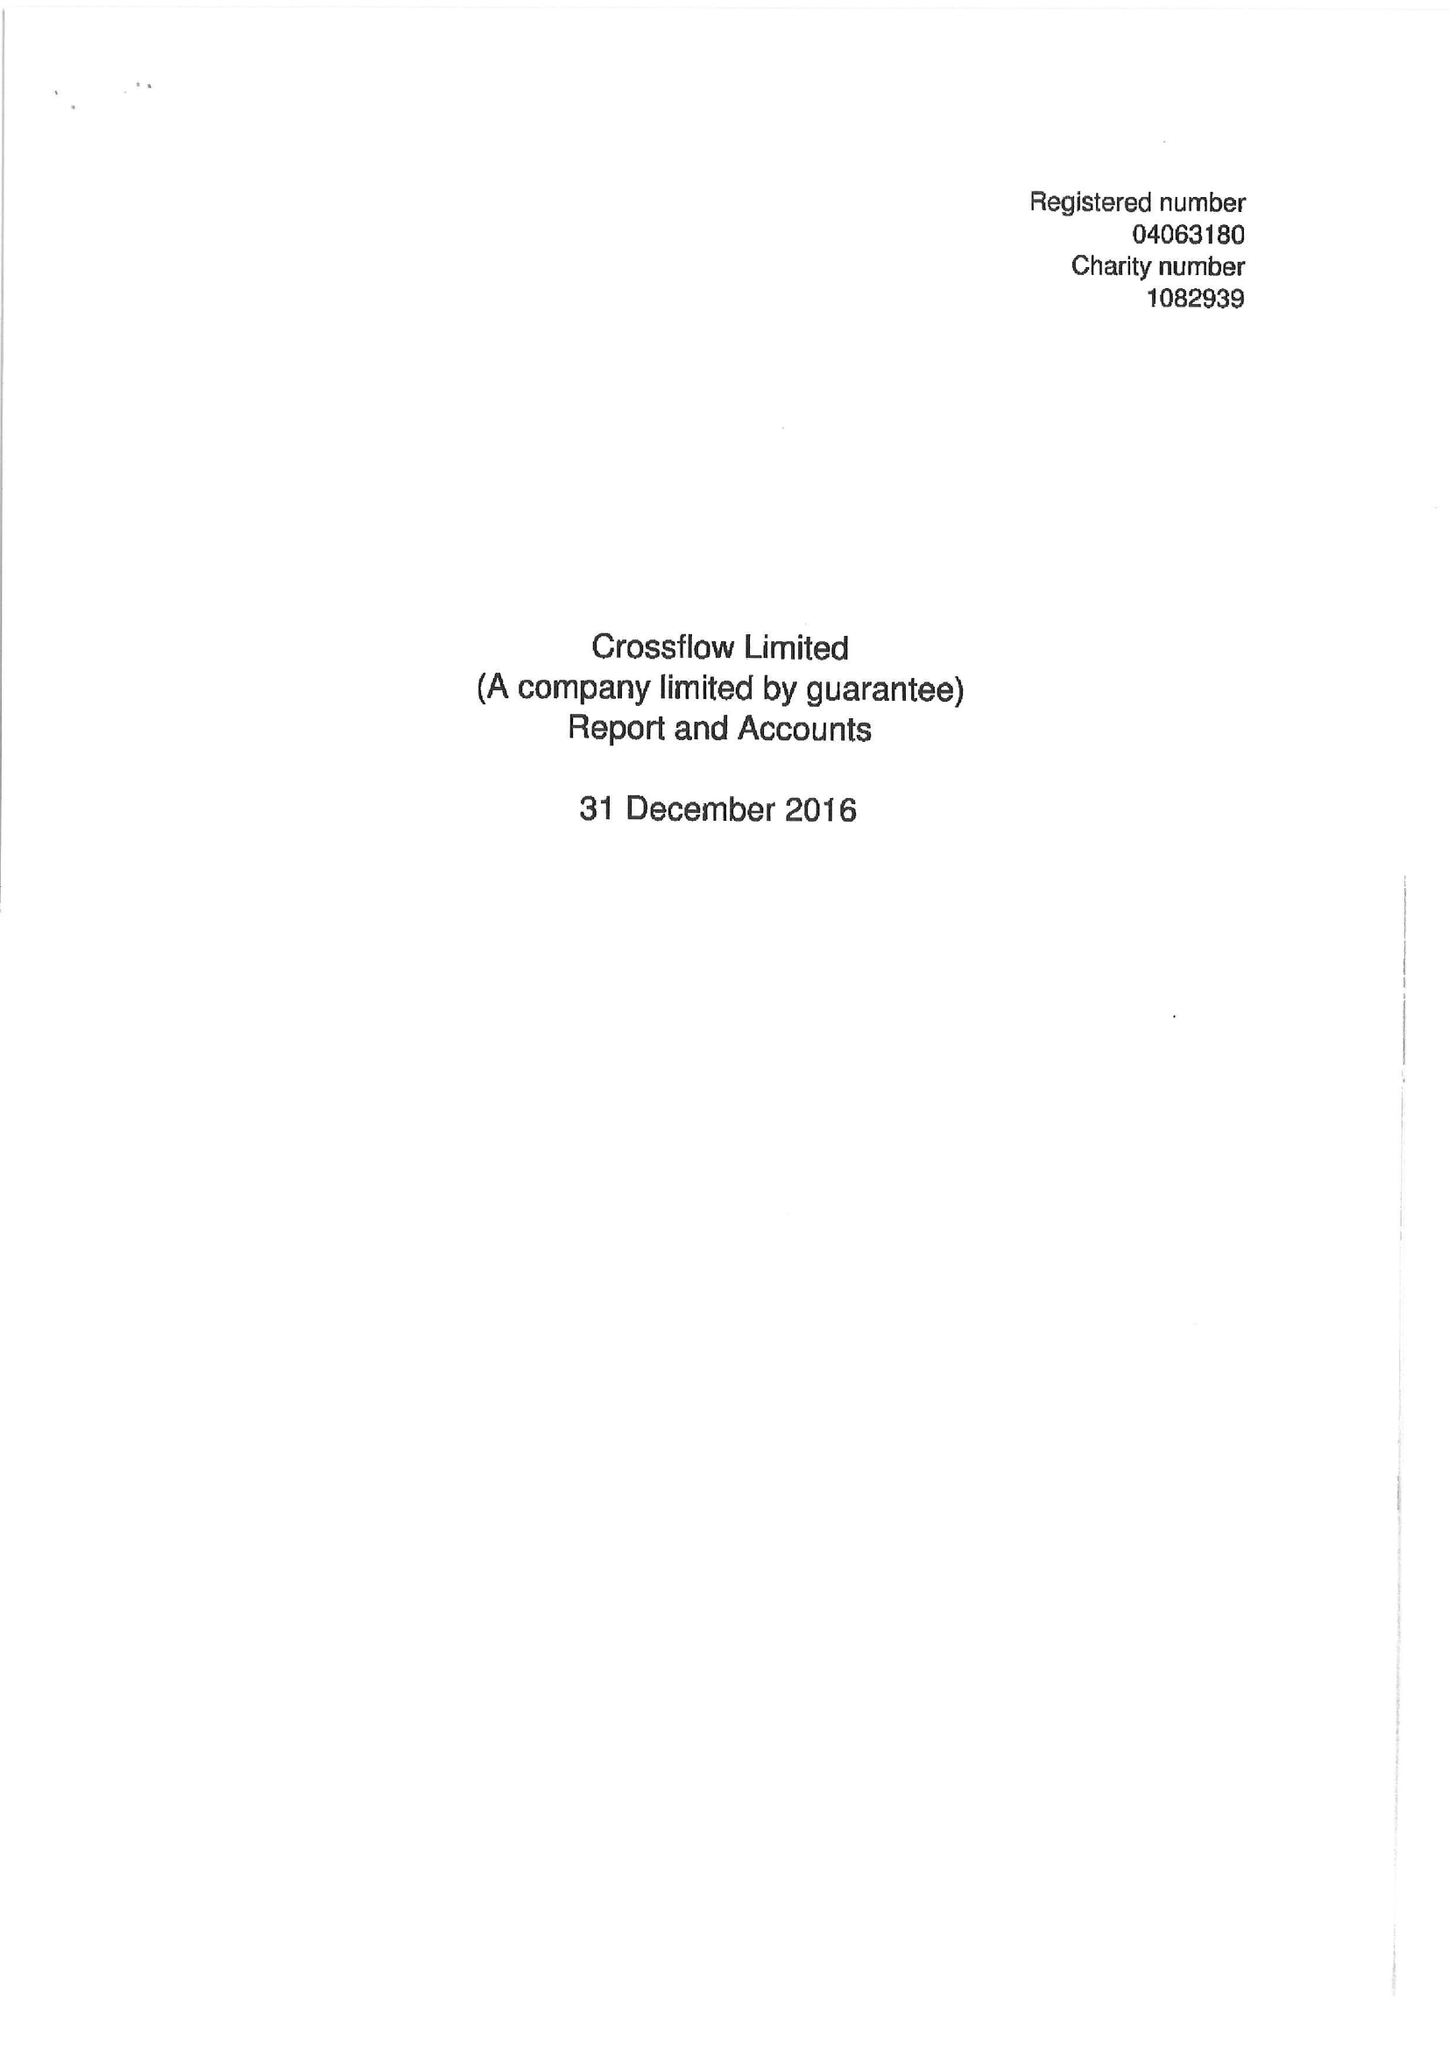What is the value for the address__post_town?
Answer the question using a single word or phrase. LONDON 